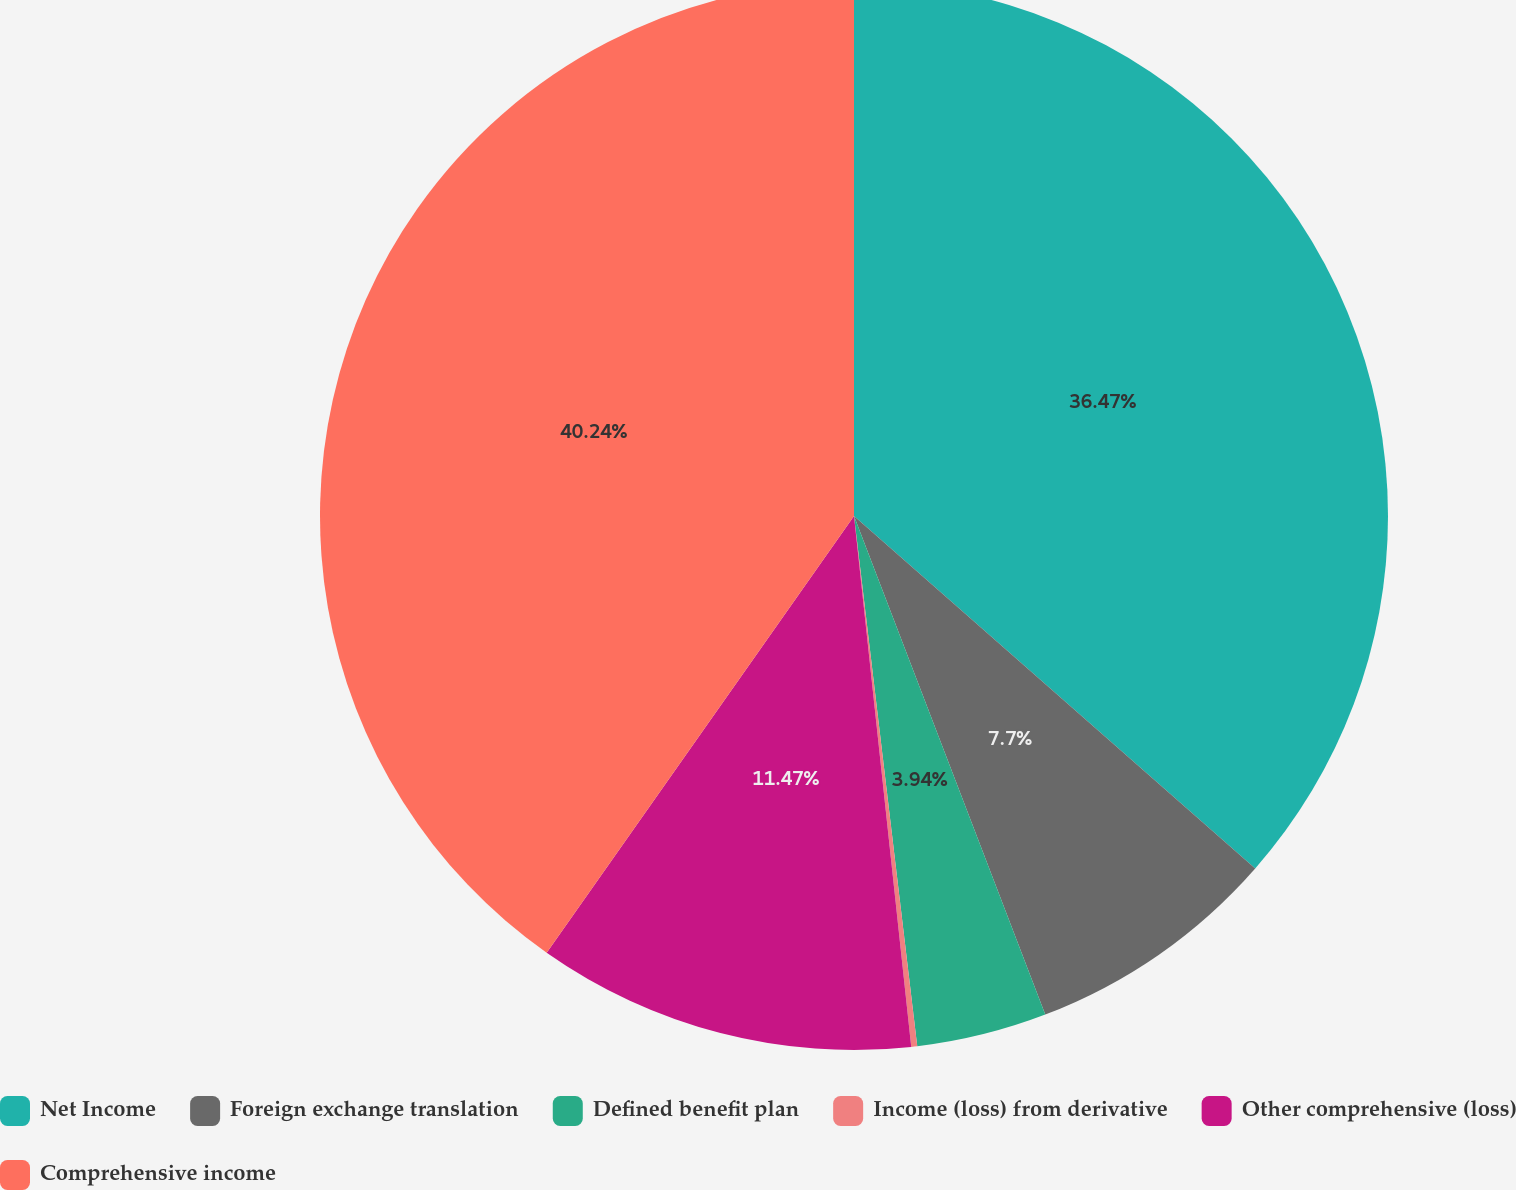Convert chart. <chart><loc_0><loc_0><loc_500><loc_500><pie_chart><fcel>Net Income<fcel>Foreign exchange translation<fcel>Defined benefit plan<fcel>Income (loss) from derivative<fcel>Other comprehensive (loss)<fcel>Comprehensive income<nl><fcel>36.47%<fcel>7.7%<fcel>3.94%<fcel>0.18%<fcel>11.47%<fcel>40.24%<nl></chart> 